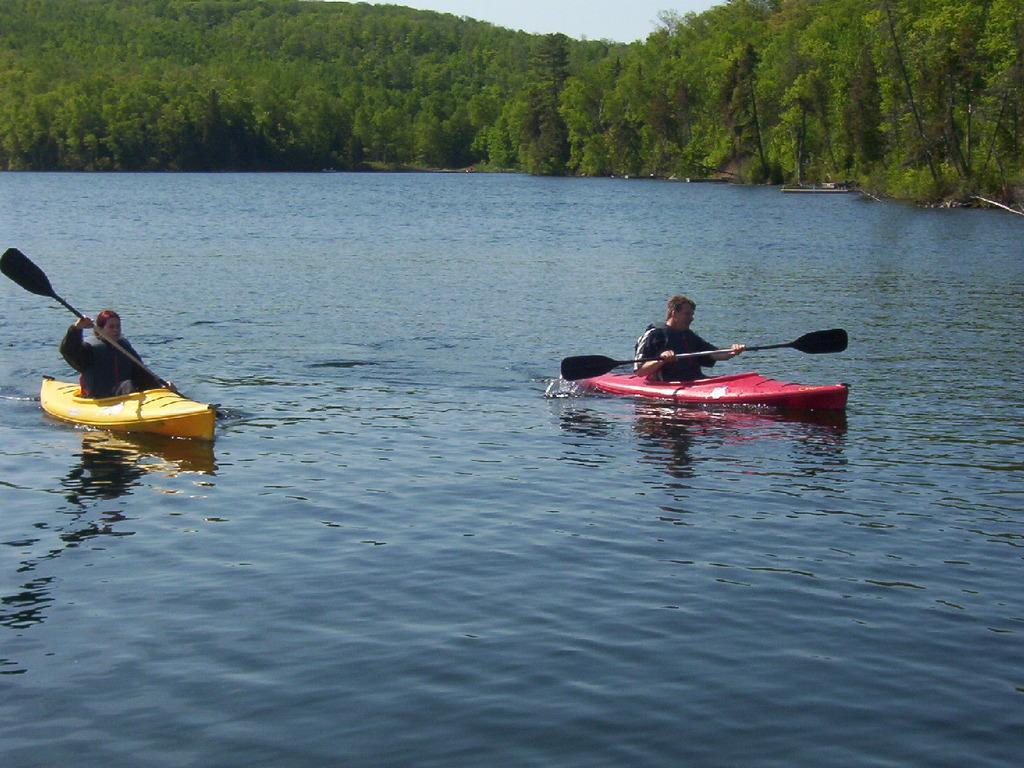Please provide a concise description of this image. In this image we can see the boats on the water. And there are two persons sitting on the boat and holding paddles. And at the back there are trees and the sky. 